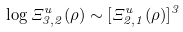<formula> <loc_0><loc_0><loc_500><loc_500>\log \Xi ^ { u } _ { 3 , 2 } ( \rho ) \sim [ \Xi ^ { u } _ { 2 , 1 } ( \rho ) ] ^ { 3 }</formula> 